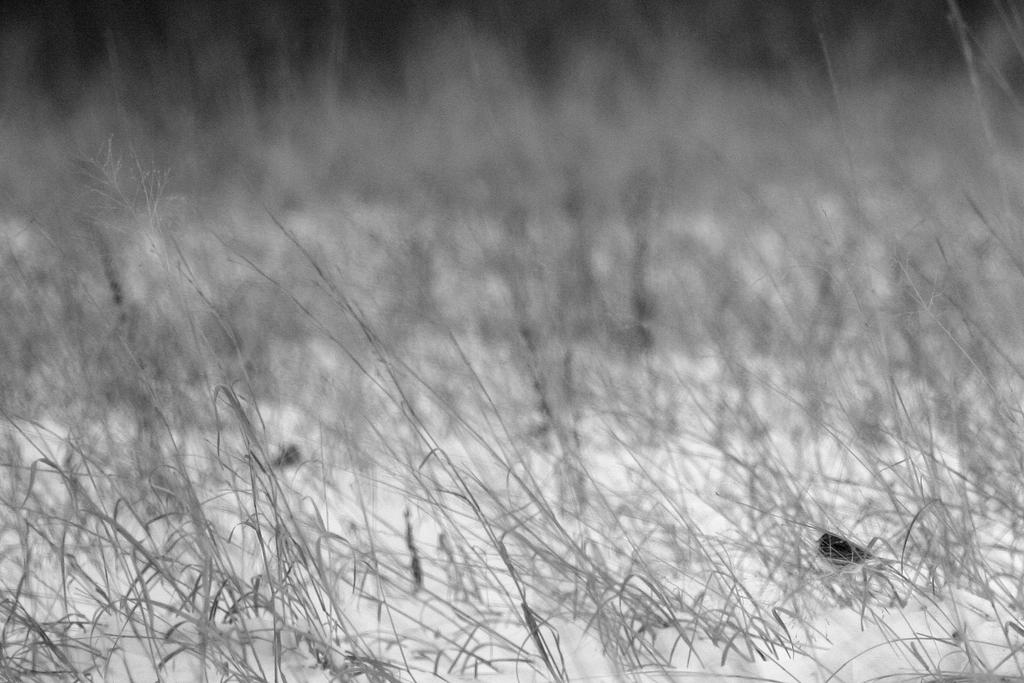What is the color scheme of the image? The image is black and white. What type of vegetation can be seen in the image? There is grass in the image. Can you describe the background of the image? The background of the image is blurred. Is there any steam coming out of the drain in the image? There is no drain or steam present in the image; it features a black and white scene with grass and a blurred background. 